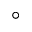Convert formula to latex. <formula><loc_0><loc_0><loc_500><loc_500>^ { \circ }</formula> 